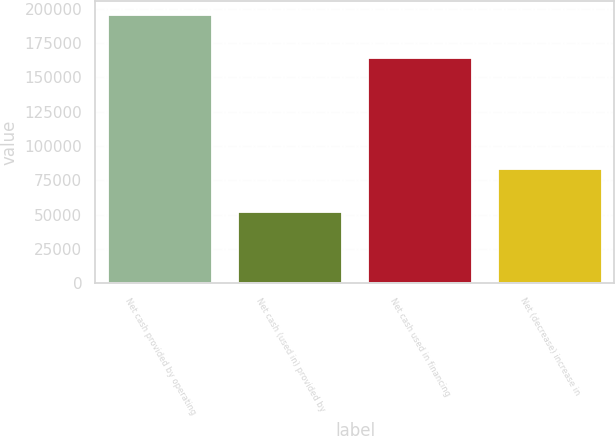<chart> <loc_0><loc_0><loc_500><loc_500><bar_chart><fcel>Net cash provided by operating<fcel>Net cash (used in) provided by<fcel>Net cash used in financing<fcel>Net (decrease) increase in<nl><fcel>195804<fcel>51545<fcel>164279<fcel>83070<nl></chart> 